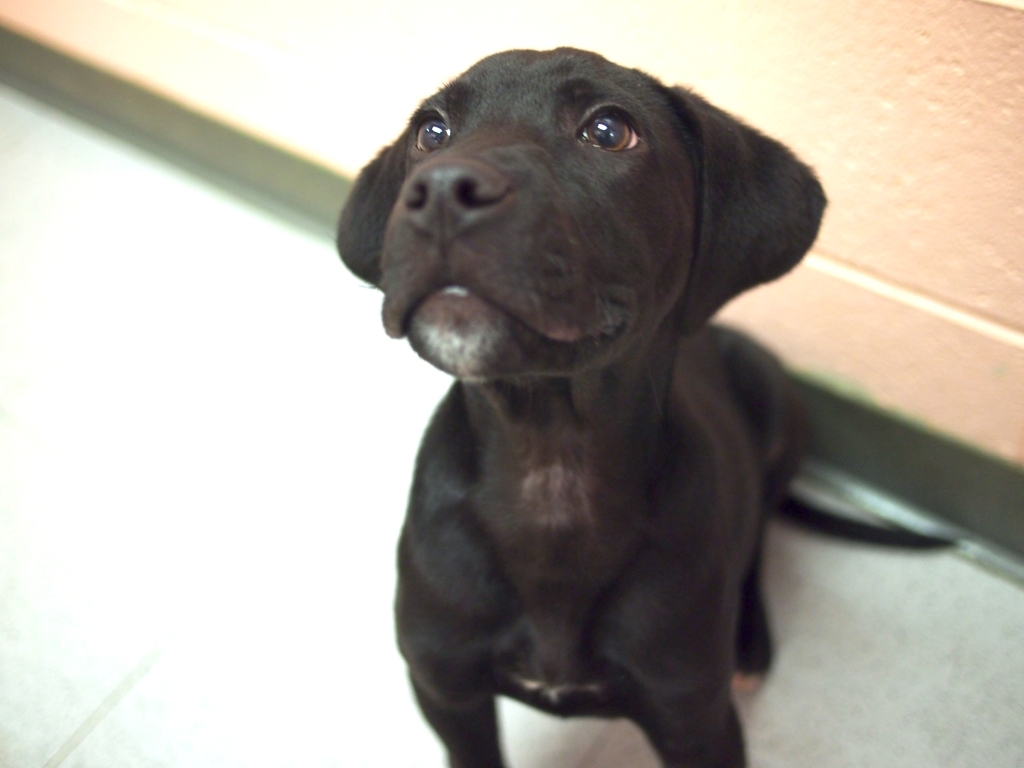Are the details and textures of the subject hard to make out? The details and textures of the subject, which is a black puppy with shiny fur, are quite discernible. The photograph captures the puppy's inquisitive expression and the light reflecting off its coat, although the image is slightly out of focus, specifically around the muzzle and the rear parts. 